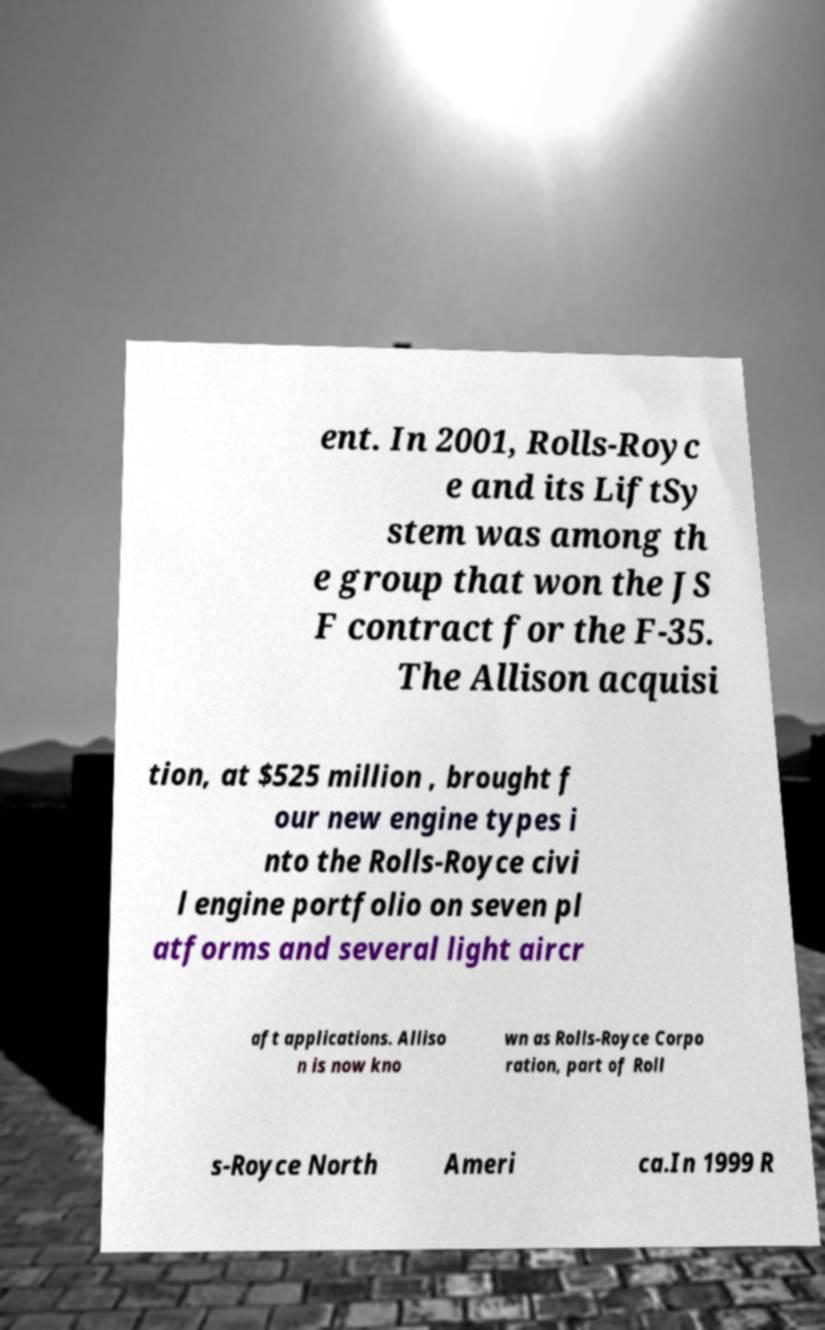There's text embedded in this image that I need extracted. Can you transcribe it verbatim? ent. In 2001, Rolls-Royc e and its LiftSy stem was among th e group that won the JS F contract for the F-35. The Allison acquisi tion, at $525 million , brought f our new engine types i nto the Rolls-Royce civi l engine portfolio on seven pl atforms and several light aircr aft applications. Alliso n is now kno wn as Rolls-Royce Corpo ration, part of Roll s-Royce North Ameri ca.In 1999 R 